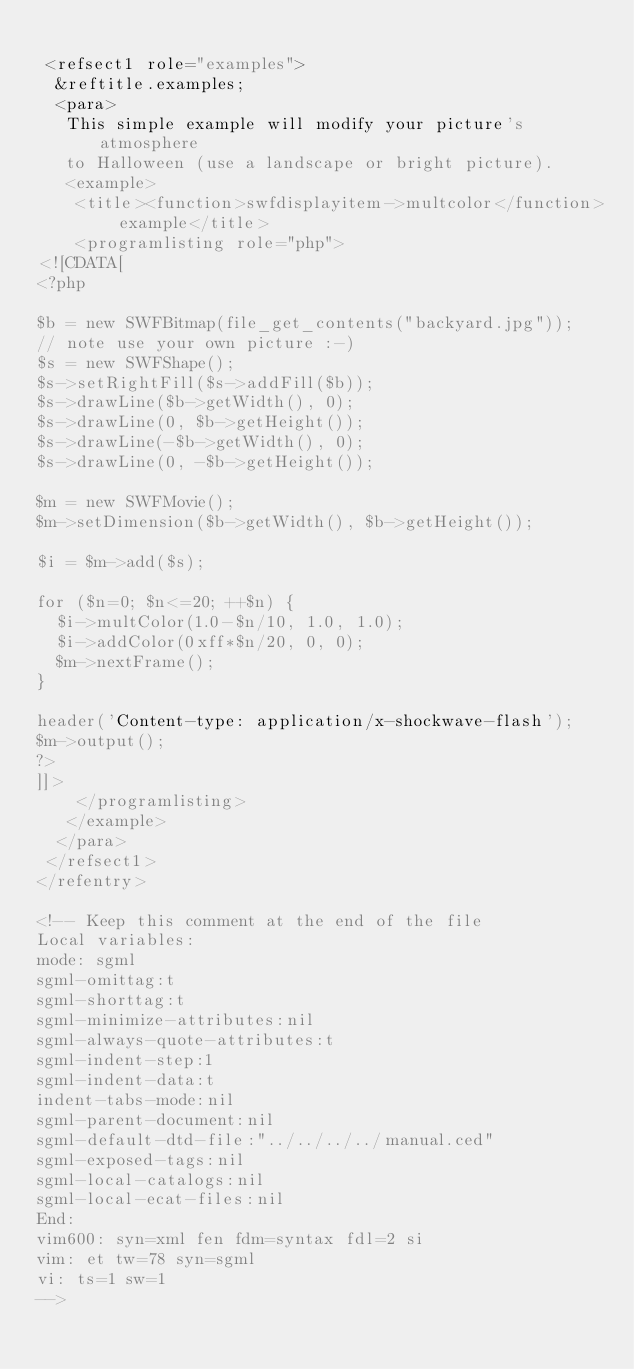Convert code to text. <code><loc_0><loc_0><loc_500><loc_500><_XML_>
 <refsect1 role="examples">
  &reftitle.examples;
  <para>
   This simple example will modify your picture's atmosphere
   to Halloween (use a landscape or bright picture).
   <example>
    <title><function>swfdisplayitem->multcolor</function> example</title>
    <programlisting role="php">
<![CDATA[
<?php

$b = new SWFBitmap(file_get_contents("backyard.jpg"));
// note use your own picture :-)
$s = new SWFShape();
$s->setRightFill($s->addFill($b));
$s->drawLine($b->getWidth(), 0);
$s->drawLine(0, $b->getHeight());
$s->drawLine(-$b->getWidth(), 0);
$s->drawLine(0, -$b->getHeight());

$m = new SWFMovie();
$m->setDimension($b->getWidth(), $b->getHeight());

$i = $m->add($s);

for ($n=0; $n<=20; ++$n) {
  $i->multColor(1.0-$n/10, 1.0, 1.0);
  $i->addColor(0xff*$n/20, 0, 0);
  $m->nextFrame();
}

header('Content-type: application/x-shockwave-flash');
$m->output();
?>
]]>
    </programlisting>
   </example>
  </para>
 </refsect1>
</refentry> 

<!-- Keep this comment at the end of the file
Local variables:
mode: sgml
sgml-omittag:t
sgml-shorttag:t
sgml-minimize-attributes:nil
sgml-always-quote-attributes:t
sgml-indent-step:1
sgml-indent-data:t
indent-tabs-mode:nil
sgml-parent-document:nil
sgml-default-dtd-file:"../../../../manual.ced"
sgml-exposed-tags:nil
sgml-local-catalogs:nil
sgml-local-ecat-files:nil
End:
vim600: syn=xml fen fdm=syntax fdl=2 si
vim: et tw=78 syn=sgml
vi: ts=1 sw=1
-->
</code> 